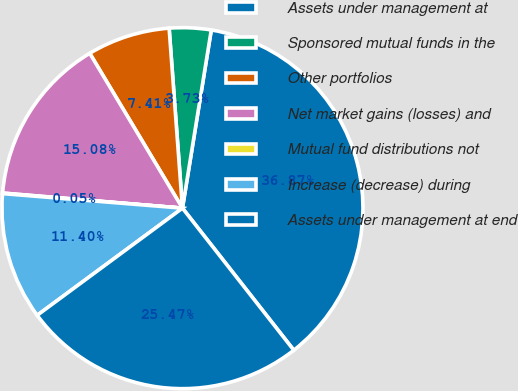<chart> <loc_0><loc_0><loc_500><loc_500><pie_chart><fcel>Assets under management at<fcel>Sponsored mutual funds in the<fcel>Other portfolios<fcel>Net market gains (losses) and<fcel>Mutual fund distributions not<fcel>Increase (decrease) during<fcel>Assets under management at end<nl><fcel>36.87%<fcel>3.73%<fcel>7.41%<fcel>15.08%<fcel>0.05%<fcel>11.4%<fcel>25.47%<nl></chart> 